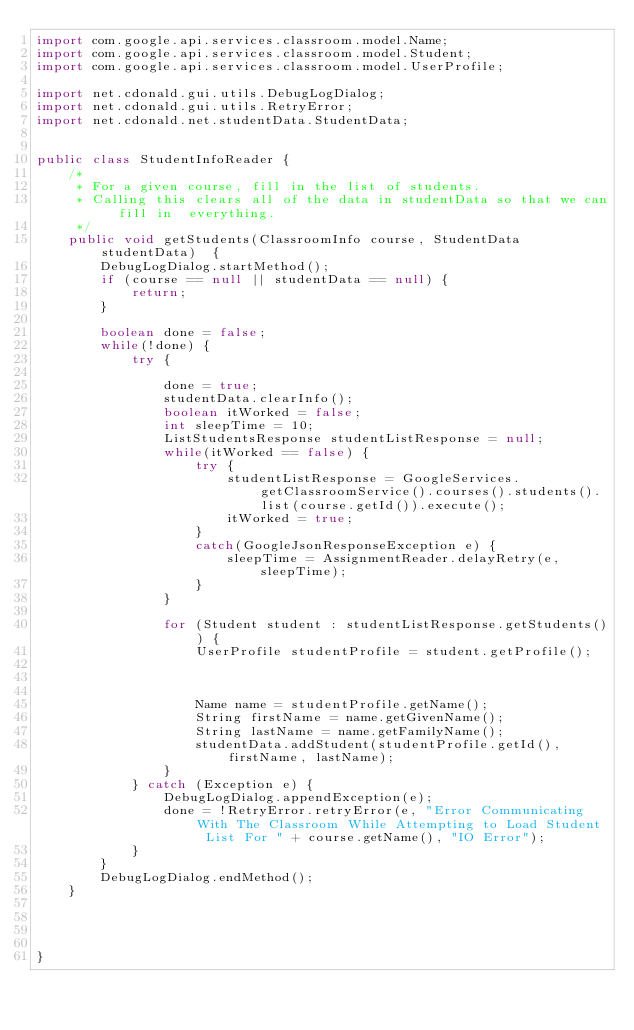<code> <loc_0><loc_0><loc_500><loc_500><_Java_>import com.google.api.services.classroom.model.Name;
import com.google.api.services.classroom.model.Student;
import com.google.api.services.classroom.model.UserProfile;

import net.cdonald.gui.utils.DebugLogDialog;
import net.cdonald.gui.utils.RetryError;
import net.cdonald.net.studentData.StudentData;


public class StudentInfoReader {
	/*
	 * For a given course, fill in the list of students.
	 * Calling this clears all of the data in studentData so that we can fill in  everything.
	 */
	public void getStudents(ClassroomInfo course, StudentData studentData)  {
		DebugLogDialog.startMethod();
		if (course == null || studentData == null) {
			return;
		}

		boolean done = false;
		while(!done) {
			try {

				done = true;
				studentData.clearInfo();				
				boolean itWorked = false;
				int sleepTime = 10;
				ListStudentsResponse studentListResponse = null;
				while(itWorked == false) {
					try {								
						studentListResponse = GoogleServices.getClassroomService().courses().students().list(course.getId()).execute();
						itWorked = true;
					}					
					catch(GoogleJsonResponseException e) {
						sleepTime = AssignmentReader.delayRetry(e, sleepTime); 
					}
				}
				
				for (Student student : studentListResponse.getStudents()) {
					UserProfile studentProfile = student.getProfile();



					Name name = studentProfile.getName();
					String firstName = name.getGivenName();
					String lastName = name.getFamilyName();
					studentData.addStudent(studentProfile.getId(), firstName, lastName);
				}
			} catch (Exception e) {
				DebugLogDialog.appendException(e);
				done = !RetryError.retryError(e, "Error Communicating With The Classroom While Attempting to Load Student List For " + course.getName(), "IO Error");
			}	
		}
		DebugLogDialog.endMethod();
	}




}
</code> 